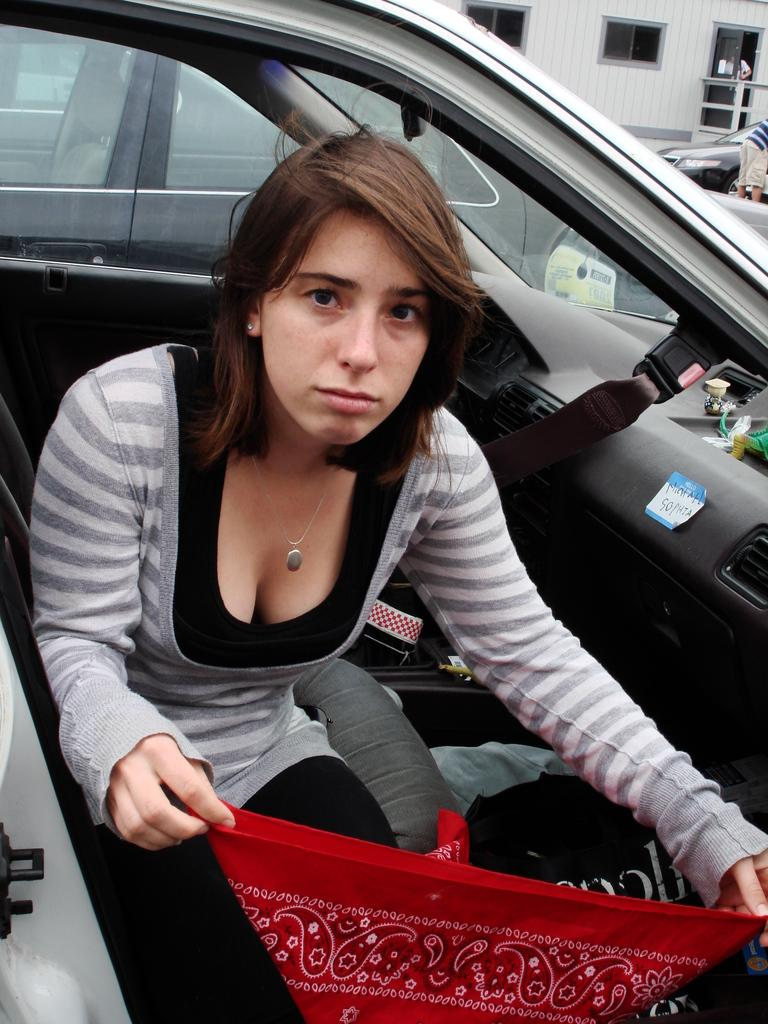Who is present in the image? There is a woman in the image. What is the woman holding in the image? The woman is holding a cloth. Where is the woman located in the image? The woman is sitting in a car. What type of observation is the woman making about the squirrel in the image? There is no squirrel present in the image, so the woman cannot be making any observations about a squirrel. 